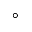<formula> <loc_0><loc_0><loc_500><loc_500>^ { \circ }</formula> 